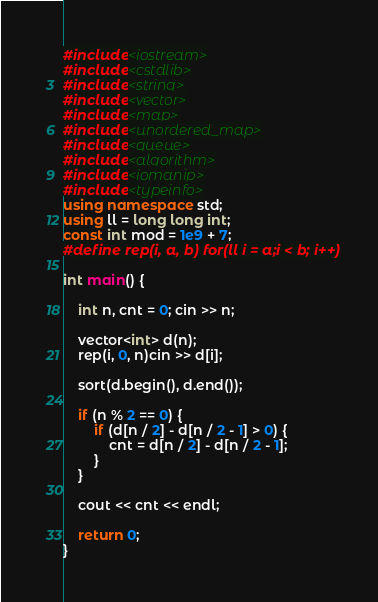Convert code to text. <code><loc_0><loc_0><loc_500><loc_500><_C++_>#include<iostream>
#include<cstdlib>
#include<string>
#include<vector>
#include<map>
#include<unordered_map>
#include<queue>
#include<algorithm>
#include<iomanip>
#include<typeinfo>
using namespace std;
using ll = long long int;
const int mod = 1e9 + 7;
#define rep(i, a, b) for(ll i = a;i < b; i++)

int main() {

	int n, cnt = 0; cin >> n;

	vector<int> d(n);
	rep(i, 0, n)cin >> d[i];

	sort(d.begin(), d.end());

	if (n % 2 == 0) {
		if (d[n / 2] - d[n / 2 - 1] > 0) {
			cnt = d[n / 2] - d[n / 2 - 1];
		}
	}

	cout << cnt << endl;

	return 0;
}
</code> 